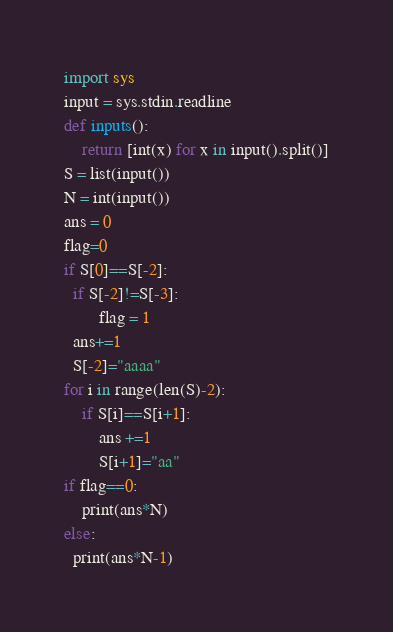<code> <loc_0><loc_0><loc_500><loc_500><_Python_>import sys
input = sys.stdin.readline
def inputs():
    return [int(x) for x in input().split()]
S = list(input())
N = int(input())
ans = 0
flag=0
if S[0]==S[-2]:
  if S[-2]!=S[-3]:
    	flag = 1
  ans+=1
  S[-2]="aaaa"
for i in range(len(S)-2):
    if S[i]==S[i+1]:
        ans +=1
        S[i+1]="aa"
if flag==0:
	print(ans*N)
else:
  print(ans*N-1)</code> 